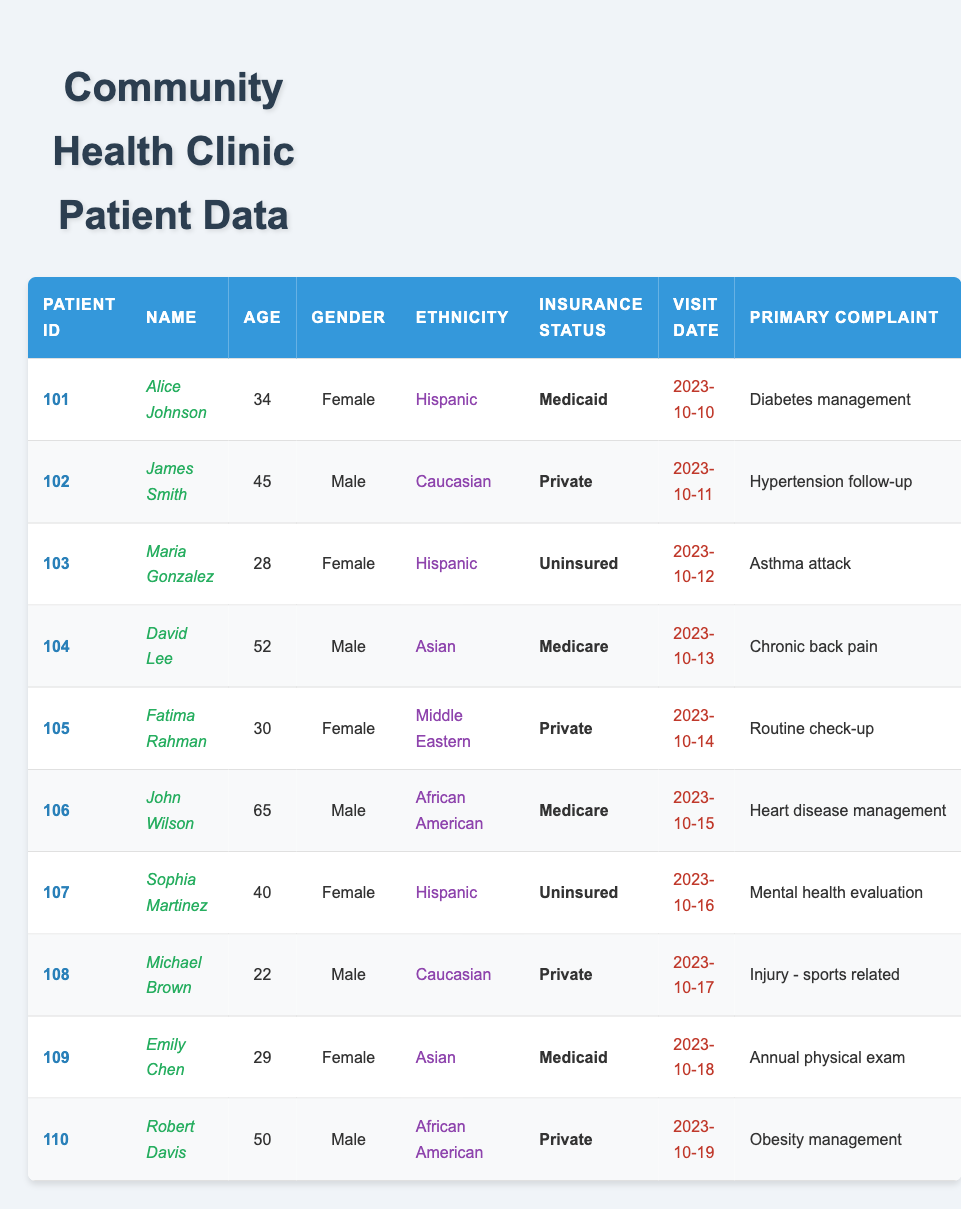What is the age of Emily Chen? Emily Chen's age is listed in the table. Referring to the row for Emily Chen, it indicates her age is 29.
Answer: 29 How many male patients are in the table? By counting the number of rows where the gender is "Male", we find that there are 5 male patients: James Smith, David Lee, John Wilson, Michael Brown, and Robert Davis.
Answer: 5 What is the primary complaint of Maria Gonzalez? The primary complaint for Maria Gonzalez is listed in her row in the table. It states that her primary complaint is "Asthma attack".
Answer: Asthma attack Is there any patient with an "Uninsured" status? Looking through the table, both Maria Gonzalez and Sophia Martinez are listed with "Uninsured" as their insurance status. Hence, there are patients with Uninsured status.
Answer: Yes What is the median age of all patients? The ages listed are 34, 45, 28, 52, 30, 65, 40, 22, 29, and 50. Arranging these in order gives: 22, 28, 29, 30, 34, 40, 45, 50, 52, 65. The median is the average of the 5th and 6th values (34 and 40), so (34 + 40)/2 = 37.
Answer: 37 What percentage of patients are covered by Medicare? There are 2 patients with Medicare out of a total of 10 patients. The percentage is calculated as (2/10) * 100 = 20%.
Answer: 20% Which ethnicity is the most common among the patients? By examining the ethnicities in the table, "Hispanic" appears 3 times, while "Caucasian", "Asian", "Middle Eastern", and "African American" appear 2, 2, 1, and 2 times respectively. So "Hispanic" is the most common ethnicity.
Answer: Hispanic What is the primary complaint of the oldest patient? John Wilson is the oldest patient at 65 years old, and his primary complaint is listed as "Heart disease management".
Answer: Heart disease management How many patients visited the clinic on October 10th or 11th? Referring to the table, Alice Johnson visited on October 10th and James Smith on October 11th, making a total of 2 patients.
Answer: 2 Are there any patients between the ages of 30 and 40? By checking the ages listed, Fatima Rahman (30), Sophia Martinez (40), and others fall into this range. Hence, there are patients in this age range.
Answer: Yes 